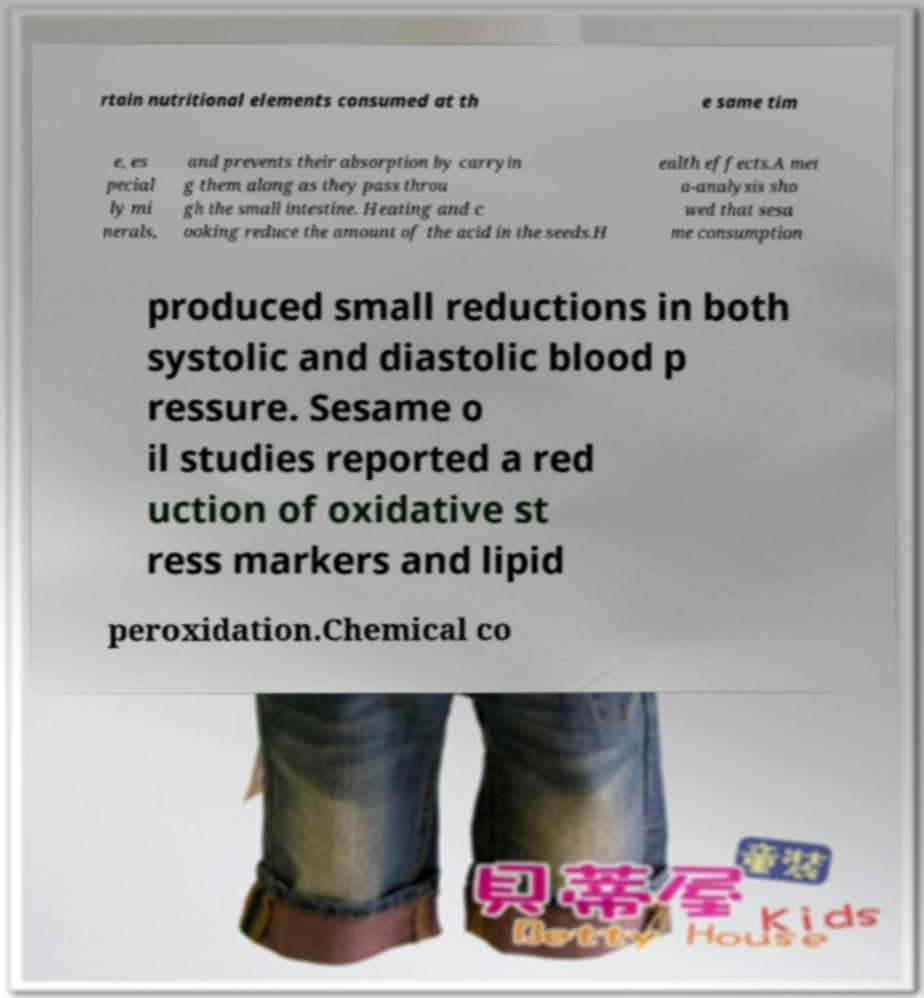Can you read and provide the text displayed in the image?This photo seems to have some interesting text. Can you extract and type it out for me? rtain nutritional elements consumed at th e same tim e, es pecial ly mi nerals, and prevents their absorption by carryin g them along as they pass throu gh the small intestine. Heating and c ooking reduce the amount of the acid in the seeds.H ealth effects.A met a-analysis sho wed that sesa me consumption produced small reductions in both systolic and diastolic blood p ressure. Sesame o il studies reported a red uction of oxidative st ress markers and lipid peroxidation.Chemical co 